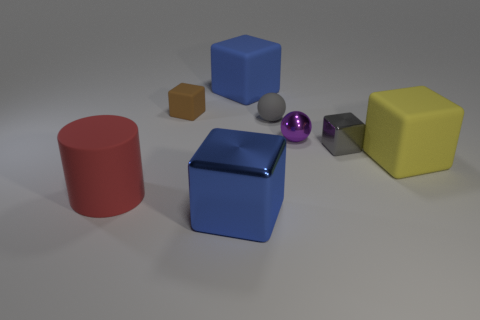Is there any indication about the light source from the shadows in the image? Yes, the direction and length of the shadows in the image imply a light source coming from the upper left side of the frame. The shadows are cast diagonally towards the lower right, suggesting a single, possibly overhead, light source. 